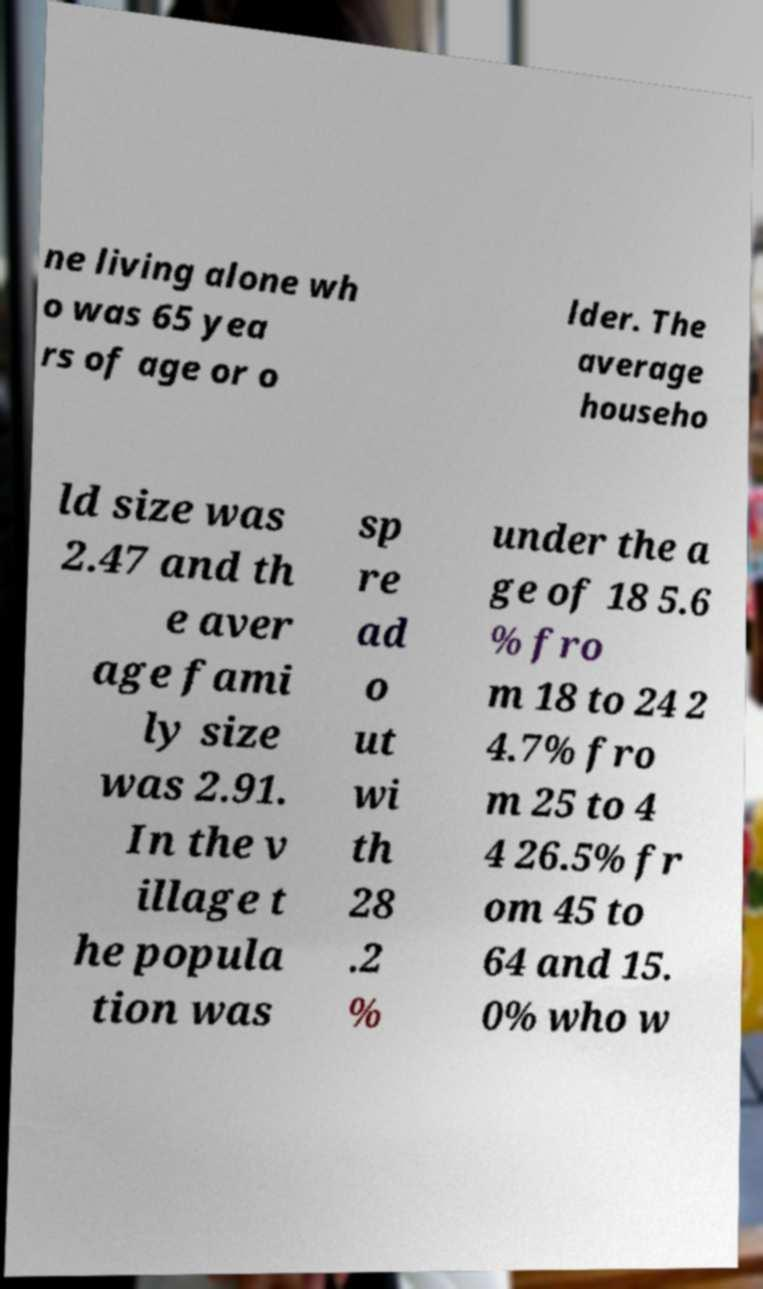Please identify and transcribe the text found in this image. ne living alone wh o was 65 yea rs of age or o lder. The average househo ld size was 2.47 and th e aver age fami ly size was 2.91. In the v illage t he popula tion was sp re ad o ut wi th 28 .2 % under the a ge of 18 5.6 % fro m 18 to 24 2 4.7% fro m 25 to 4 4 26.5% fr om 45 to 64 and 15. 0% who w 